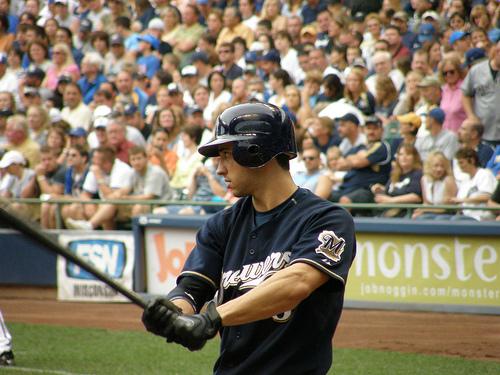Which game is being played?
Short answer required. Baseball. What color is his helmet?
Quick response, please. Black. How many people in the shot?
Short answer required. Lot. 